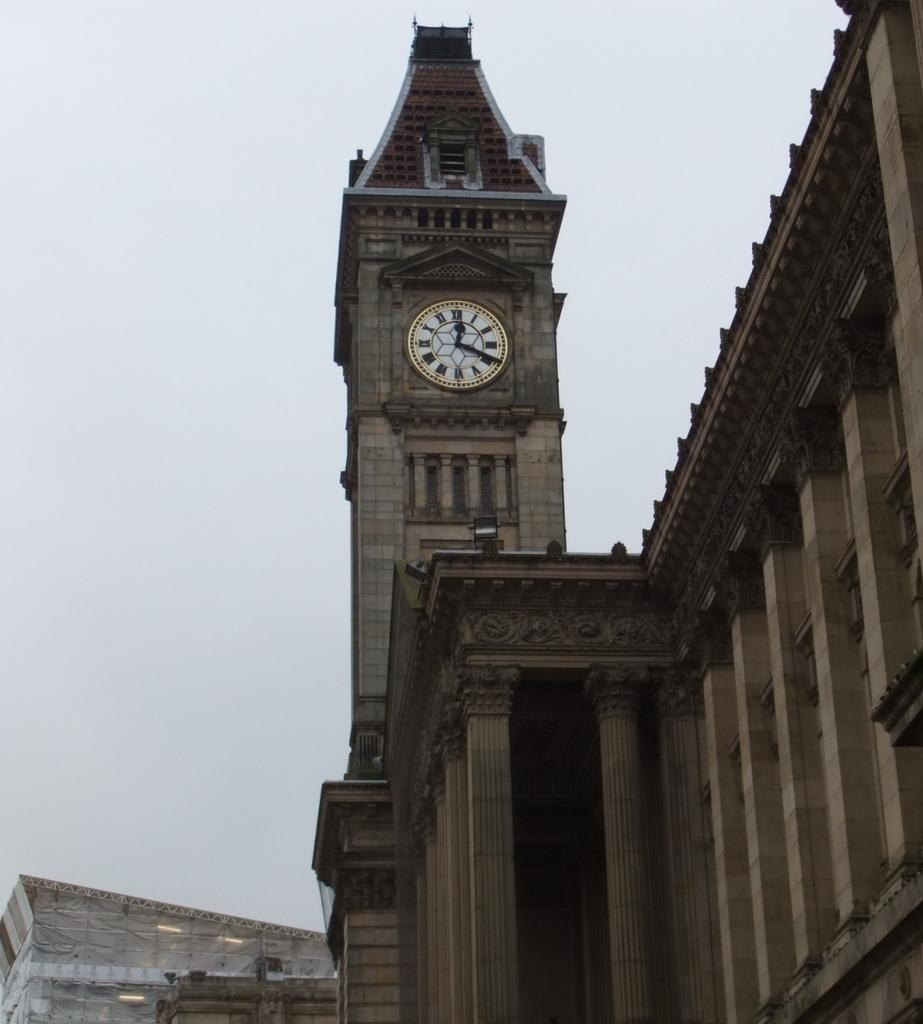What type of structures can be seen in the image? There are buildings in the image. Can you identify any specific features on the buildings? Yes, there is a clock on one of the buildings. What architectural elements are visible in the image? There are pillars visible in the image. What is visible in the background of the image? The sky is visible in the image. Can you tell me how many aunts are playing the drum in the image? There are no aunts or drums present in the image. 